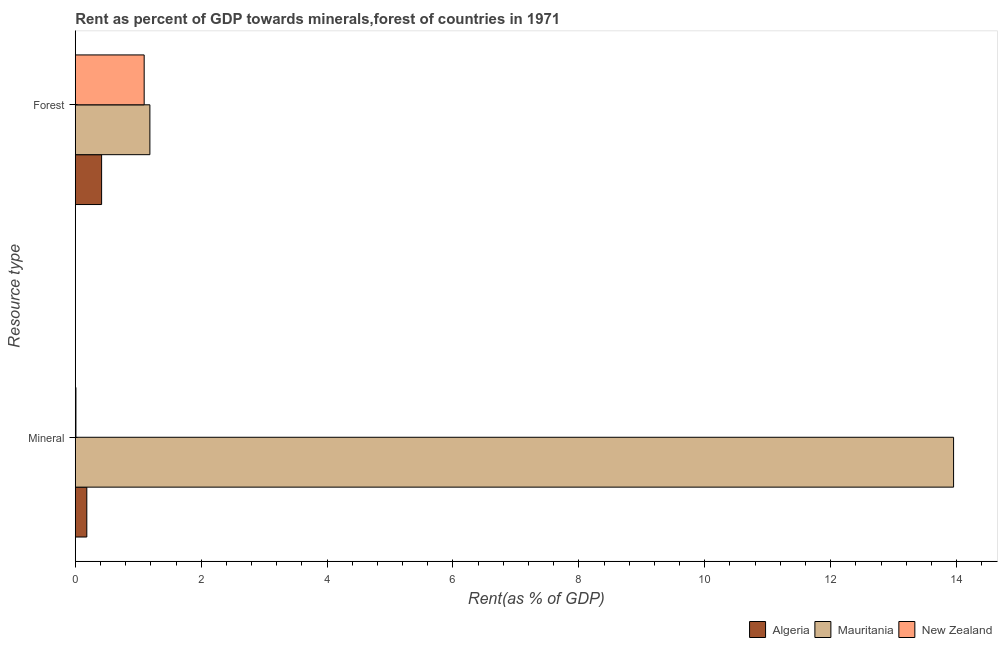Are the number of bars on each tick of the Y-axis equal?
Your response must be concise. Yes. How many bars are there on the 1st tick from the top?
Your response must be concise. 3. How many bars are there on the 1st tick from the bottom?
Give a very brief answer. 3. What is the label of the 2nd group of bars from the top?
Your response must be concise. Mineral. What is the mineral rent in Algeria?
Provide a short and direct response. 0.18. Across all countries, what is the maximum forest rent?
Ensure brevity in your answer.  1.19. Across all countries, what is the minimum mineral rent?
Offer a very short reply. 0.01. In which country was the mineral rent maximum?
Ensure brevity in your answer.  Mauritania. In which country was the mineral rent minimum?
Provide a short and direct response. New Zealand. What is the total forest rent in the graph?
Provide a succinct answer. 2.7. What is the difference between the mineral rent in Algeria and that in Mauritania?
Provide a short and direct response. -13.77. What is the difference between the forest rent in Algeria and the mineral rent in Mauritania?
Provide a succinct answer. -13.53. What is the average forest rent per country?
Provide a succinct answer. 0.9. What is the difference between the forest rent and mineral rent in New Zealand?
Keep it short and to the point. 1.08. What is the ratio of the mineral rent in Algeria to that in New Zealand?
Your answer should be very brief. 18.25. Is the mineral rent in Mauritania less than that in Algeria?
Give a very brief answer. No. In how many countries, is the mineral rent greater than the average mineral rent taken over all countries?
Keep it short and to the point. 1. What does the 3rd bar from the top in Mineral represents?
Your answer should be compact. Algeria. What does the 1st bar from the bottom in Forest represents?
Provide a succinct answer. Algeria. What is the difference between two consecutive major ticks on the X-axis?
Offer a terse response. 2. Does the graph contain grids?
Give a very brief answer. No. Where does the legend appear in the graph?
Offer a very short reply. Bottom right. How many legend labels are there?
Provide a succinct answer. 3. What is the title of the graph?
Make the answer very short. Rent as percent of GDP towards minerals,forest of countries in 1971. What is the label or title of the X-axis?
Offer a terse response. Rent(as % of GDP). What is the label or title of the Y-axis?
Offer a very short reply. Resource type. What is the Rent(as % of GDP) in Algeria in Mineral?
Your answer should be very brief. 0.18. What is the Rent(as % of GDP) of Mauritania in Mineral?
Your answer should be very brief. 13.95. What is the Rent(as % of GDP) in New Zealand in Mineral?
Keep it short and to the point. 0.01. What is the Rent(as % of GDP) of Algeria in Forest?
Offer a terse response. 0.42. What is the Rent(as % of GDP) in Mauritania in Forest?
Provide a succinct answer. 1.19. What is the Rent(as % of GDP) of New Zealand in Forest?
Your answer should be compact. 1.09. Across all Resource type, what is the maximum Rent(as % of GDP) of Algeria?
Offer a very short reply. 0.42. Across all Resource type, what is the maximum Rent(as % of GDP) in Mauritania?
Make the answer very short. 13.95. Across all Resource type, what is the maximum Rent(as % of GDP) of New Zealand?
Your response must be concise. 1.09. Across all Resource type, what is the minimum Rent(as % of GDP) in Algeria?
Your response must be concise. 0.18. Across all Resource type, what is the minimum Rent(as % of GDP) of Mauritania?
Offer a terse response. 1.19. Across all Resource type, what is the minimum Rent(as % of GDP) in New Zealand?
Give a very brief answer. 0.01. What is the total Rent(as % of GDP) of Algeria in the graph?
Offer a very short reply. 0.6. What is the total Rent(as % of GDP) in Mauritania in the graph?
Provide a short and direct response. 15.14. What is the total Rent(as % of GDP) of New Zealand in the graph?
Provide a short and direct response. 1.1. What is the difference between the Rent(as % of GDP) in Algeria in Mineral and that in Forest?
Ensure brevity in your answer.  -0.23. What is the difference between the Rent(as % of GDP) in Mauritania in Mineral and that in Forest?
Ensure brevity in your answer.  12.77. What is the difference between the Rent(as % of GDP) of New Zealand in Mineral and that in Forest?
Make the answer very short. -1.08. What is the difference between the Rent(as % of GDP) in Algeria in Mineral and the Rent(as % of GDP) in Mauritania in Forest?
Keep it short and to the point. -1. What is the difference between the Rent(as % of GDP) in Algeria in Mineral and the Rent(as % of GDP) in New Zealand in Forest?
Give a very brief answer. -0.91. What is the difference between the Rent(as % of GDP) in Mauritania in Mineral and the Rent(as % of GDP) in New Zealand in Forest?
Keep it short and to the point. 12.86. What is the average Rent(as % of GDP) in Algeria per Resource type?
Ensure brevity in your answer.  0.3. What is the average Rent(as % of GDP) of Mauritania per Resource type?
Offer a terse response. 7.57. What is the average Rent(as % of GDP) of New Zealand per Resource type?
Your answer should be very brief. 0.55. What is the difference between the Rent(as % of GDP) of Algeria and Rent(as % of GDP) of Mauritania in Mineral?
Give a very brief answer. -13.77. What is the difference between the Rent(as % of GDP) of Algeria and Rent(as % of GDP) of New Zealand in Mineral?
Ensure brevity in your answer.  0.17. What is the difference between the Rent(as % of GDP) in Mauritania and Rent(as % of GDP) in New Zealand in Mineral?
Your response must be concise. 13.94. What is the difference between the Rent(as % of GDP) of Algeria and Rent(as % of GDP) of Mauritania in Forest?
Provide a short and direct response. -0.77. What is the difference between the Rent(as % of GDP) of Algeria and Rent(as % of GDP) of New Zealand in Forest?
Offer a terse response. -0.68. What is the difference between the Rent(as % of GDP) of Mauritania and Rent(as % of GDP) of New Zealand in Forest?
Your answer should be compact. 0.09. What is the ratio of the Rent(as % of GDP) in Algeria in Mineral to that in Forest?
Give a very brief answer. 0.44. What is the ratio of the Rent(as % of GDP) of Mauritania in Mineral to that in Forest?
Give a very brief answer. 11.77. What is the ratio of the Rent(as % of GDP) in New Zealand in Mineral to that in Forest?
Offer a very short reply. 0.01. What is the difference between the highest and the second highest Rent(as % of GDP) of Algeria?
Offer a terse response. 0.23. What is the difference between the highest and the second highest Rent(as % of GDP) of Mauritania?
Give a very brief answer. 12.77. What is the difference between the highest and the second highest Rent(as % of GDP) of New Zealand?
Your response must be concise. 1.08. What is the difference between the highest and the lowest Rent(as % of GDP) of Algeria?
Your answer should be very brief. 0.23. What is the difference between the highest and the lowest Rent(as % of GDP) in Mauritania?
Ensure brevity in your answer.  12.77. What is the difference between the highest and the lowest Rent(as % of GDP) of New Zealand?
Give a very brief answer. 1.08. 